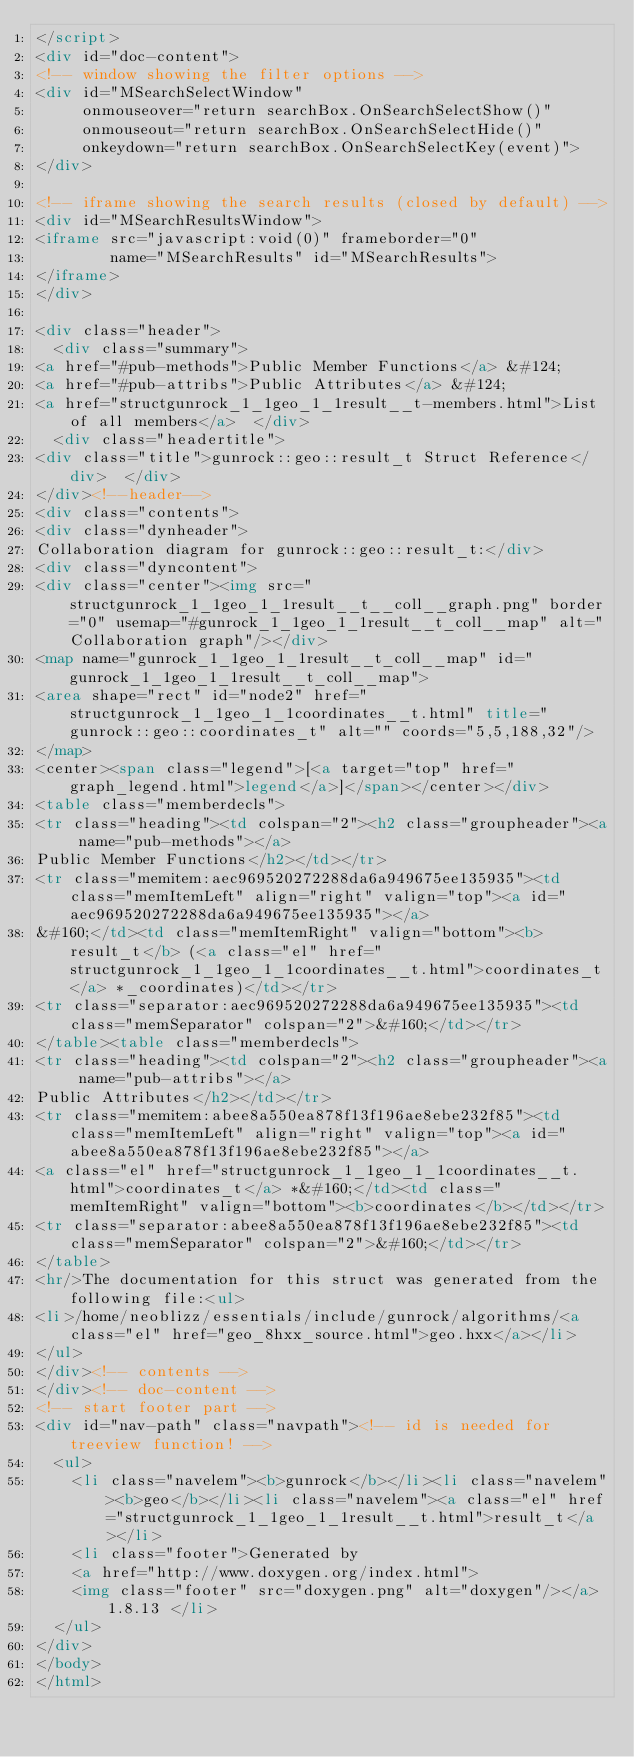<code> <loc_0><loc_0><loc_500><loc_500><_HTML_></script>
<div id="doc-content">
<!-- window showing the filter options -->
<div id="MSearchSelectWindow"
     onmouseover="return searchBox.OnSearchSelectShow()"
     onmouseout="return searchBox.OnSearchSelectHide()"
     onkeydown="return searchBox.OnSearchSelectKey(event)">
</div>

<!-- iframe showing the search results (closed by default) -->
<div id="MSearchResultsWindow">
<iframe src="javascript:void(0)" frameborder="0" 
        name="MSearchResults" id="MSearchResults">
</iframe>
</div>

<div class="header">
  <div class="summary">
<a href="#pub-methods">Public Member Functions</a> &#124;
<a href="#pub-attribs">Public Attributes</a> &#124;
<a href="structgunrock_1_1geo_1_1result__t-members.html">List of all members</a>  </div>
  <div class="headertitle">
<div class="title">gunrock::geo::result_t Struct Reference</div>  </div>
</div><!--header-->
<div class="contents">
<div class="dynheader">
Collaboration diagram for gunrock::geo::result_t:</div>
<div class="dyncontent">
<div class="center"><img src="structgunrock_1_1geo_1_1result__t__coll__graph.png" border="0" usemap="#gunrock_1_1geo_1_1result__t_coll__map" alt="Collaboration graph"/></div>
<map name="gunrock_1_1geo_1_1result__t_coll__map" id="gunrock_1_1geo_1_1result__t_coll__map">
<area shape="rect" id="node2" href="structgunrock_1_1geo_1_1coordinates__t.html" title="gunrock::geo::coordinates_t" alt="" coords="5,5,188,32"/>
</map>
<center><span class="legend">[<a target="top" href="graph_legend.html">legend</a>]</span></center></div>
<table class="memberdecls">
<tr class="heading"><td colspan="2"><h2 class="groupheader"><a name="pub-methods"></a>
Public Member Functions</h2></td></tr>
<tr class="memitem:aec969520272288da6a949675ee135935"><td class="memItemLeft" align="right" valign="top"><a id="aec969520272288da6a949675ee135935"></a>
&#160;</td><td class="memItemRight" valign="bottom"><b>result_t</b> (<a class="el" href="structgunrock_1_1geo_1_1coordinates__t.html">coordinates_t</a> *_coordinates)</td></tr>
<tr class="separator:aec969520272288da6a949675ee135935"><td class="memSeparator" colspan="2">&#160;</td></tr>
</table><table class="memberdecls">
<tr class="heading"><td colspan="2"><h2 class="groupheader"><a name="pub-attribs"></a>
Public Attributes</h2></td></tr>
<tr class="memitem:abee8a550ea878f13f196ae8ebe232f85"><td class="memItemLeft" align="right" valign="top"><a id="abee8a550ea878f13f196ae8ebe232f85"></a>
<a class="el" href="structgunrock_1_1geo_1_1coordinates__t.html">coordinates_t</a> *&#160;</td><td class="memItemRight" valign="bottom"><b>coordinates</b></td></tr>
<tr class="separator:abee8a550ea878f13f196ae8ebe232f85"><td class="memSeparator" colspan="2">&#160;</td></tr>
</table>
<hr/>The documentation for this struct was generated from the following file:<ul>
<li>/home/neoblizz/essentials/include/gunrock/algorithms/<a class="el" href="geo_8hxx_source.html">geo.hxx</a></li>
</ul>
</div><!-- contents -->
</div><!-- doc-content -->
<!-- start footer part -->
<div id="nav-path" class="navpath"><!-- id is needed for treeview function! -->
  <ul>
    <li class="navelem"><b>gunrock</b></li><li class="navelem"><b>geo</b></li><li class="navelem"><a class="el" href="structgunrock_1_1geo_1_1result__t.html">result_t</a></li>
    <li class="footer">Generated by
    <a href="http://www.doxygen.org/index.html">
    <img class="footer" src="doxygen.png" alt="doxygen"/></a> 1.8.13 </li>
  </ul>
</div>
</body>
</html>
</code> 